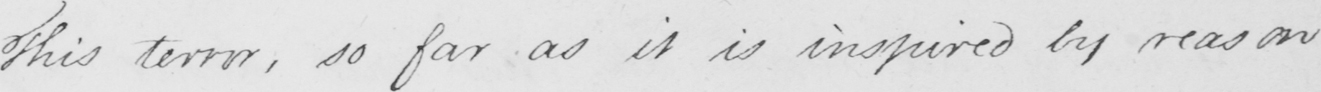What does this handwritten line say? This terror , so far as it is inspired by reason 